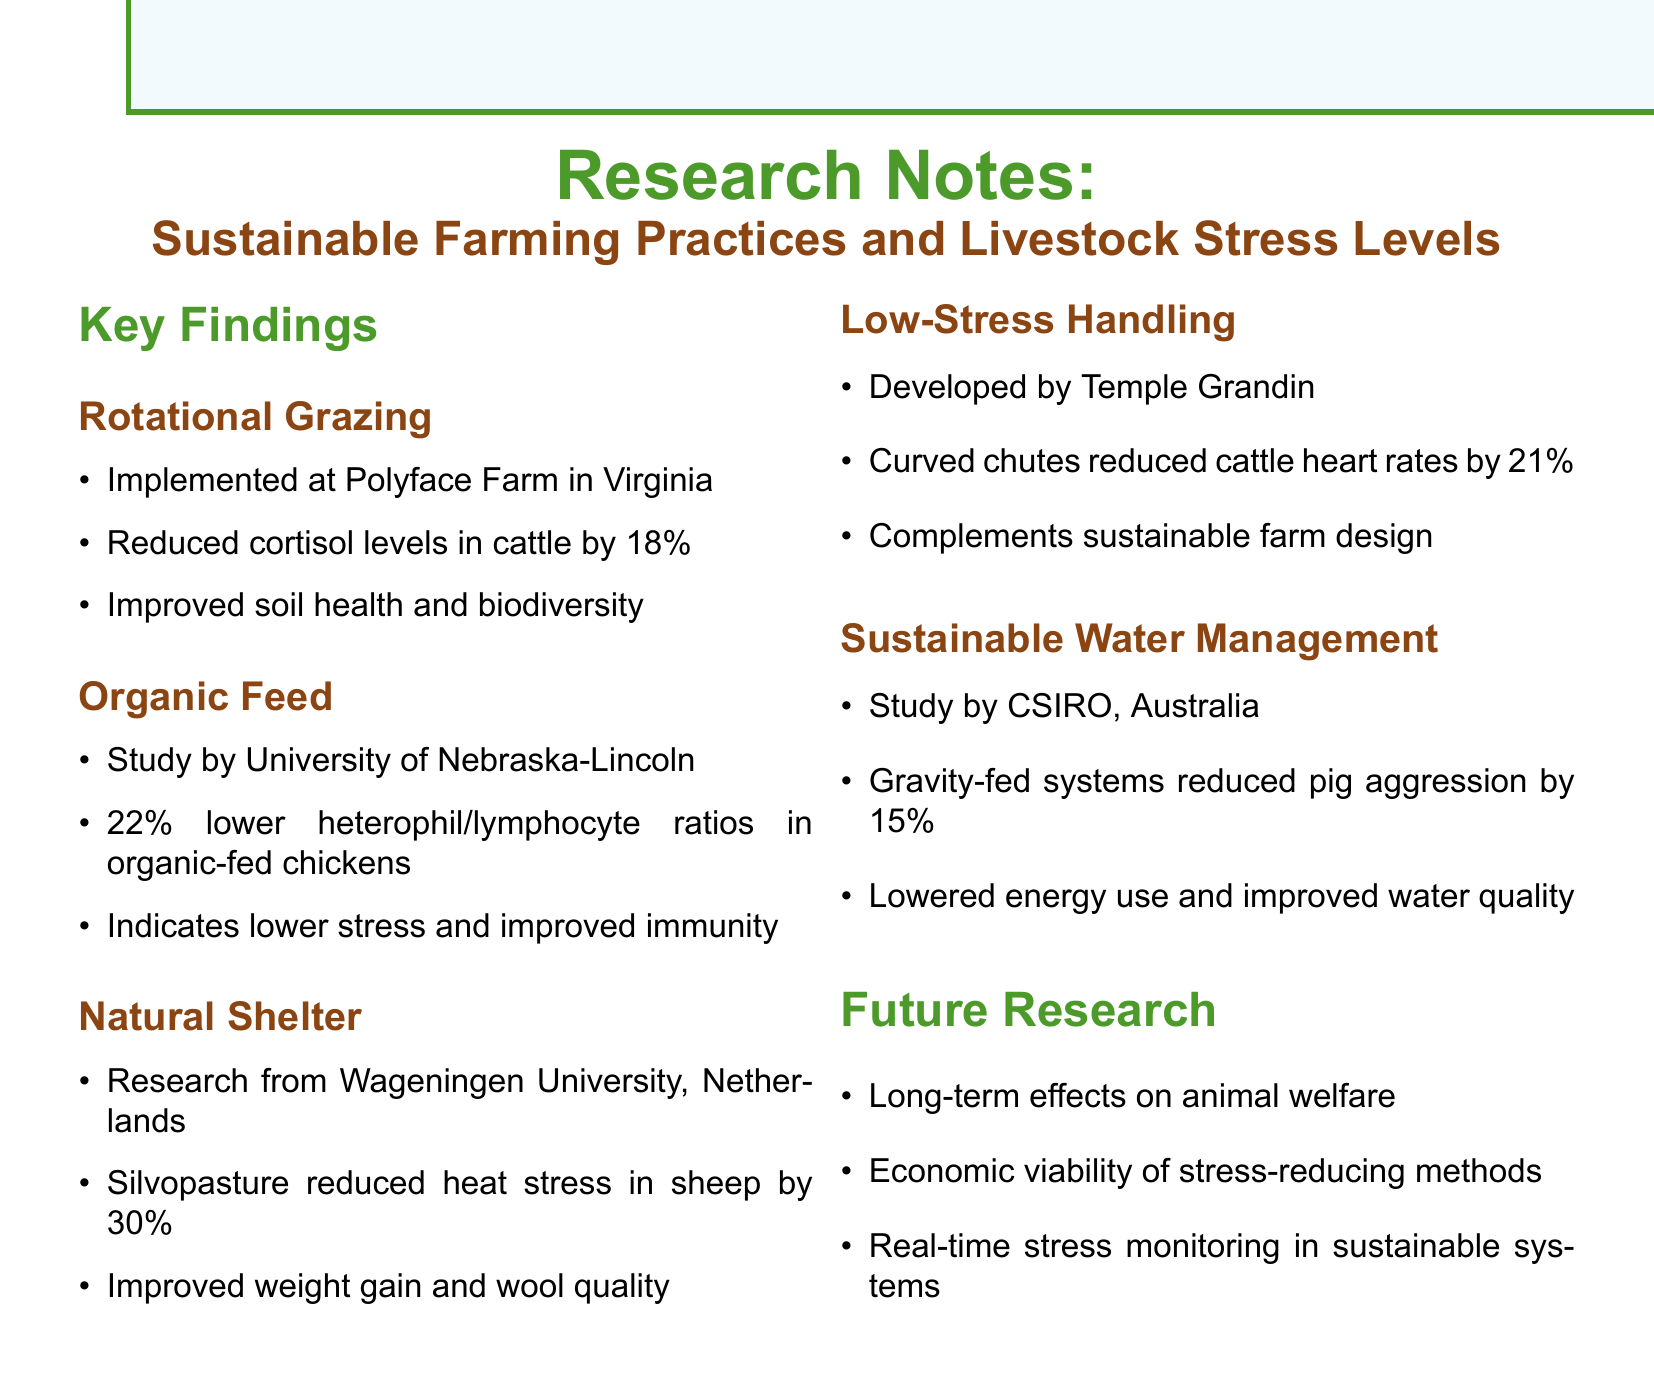What farming practice was implemented at Polyface Farm? The document mentions Polyface Farm in Virginia, where Rotational Grazing was implemented.
Answer: Rotational Grazing By what percentage did cortisol levels in cattle reduce with rotational grazing? The document states that rotational grazing reduced cortisol levels in cattle by 18%.
Answer: 18% What university conducted the study on organic feed and stress reduction? The document cites the University of Nebraska-Lincoln as the institution behind the organic feed study.
Answer: University of Nebraska-Lincoln How much did silvopasture reduce heat stress in sheep? According to the findings, silvopasture reduced heat stress in sheep by 30%.
Answer: 30% What innovative concept did Temple Grandin develop to reduce stress in cattle? The document refers to low-stress handling techniques developed by Temple Grandin focusing on curved chutes.
Answer: Low-Stress Handling Techniques What was the percentage decrease in pig aggression linked to gravity-fed water systems? The research indicated that gravity-fed water systems reduced pig aggression by 15%.
Answer: 15% What future research direction is mentioned regarding economic aspects? The document notes the economic viability of stress-reducing sustainable methods as a future research direction.
Answer: Economic viability What specific feature of sustainable water management improved water quality? The document mentions that gravity-fed systems lowered energy consumption and improved water quality.
Answer: Gravity-fed systems What are the suggested methods for real-time stress monitoring? The document suggests the integration of technology for real-time stress monitoring in sustainable systems as a future research direction.
Answer: Technology for real-time stress monitoring 